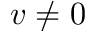Convert formula to latex. <formula><loc_0><loc_0><loc_500><loc_500>v \neq 0</formula> 